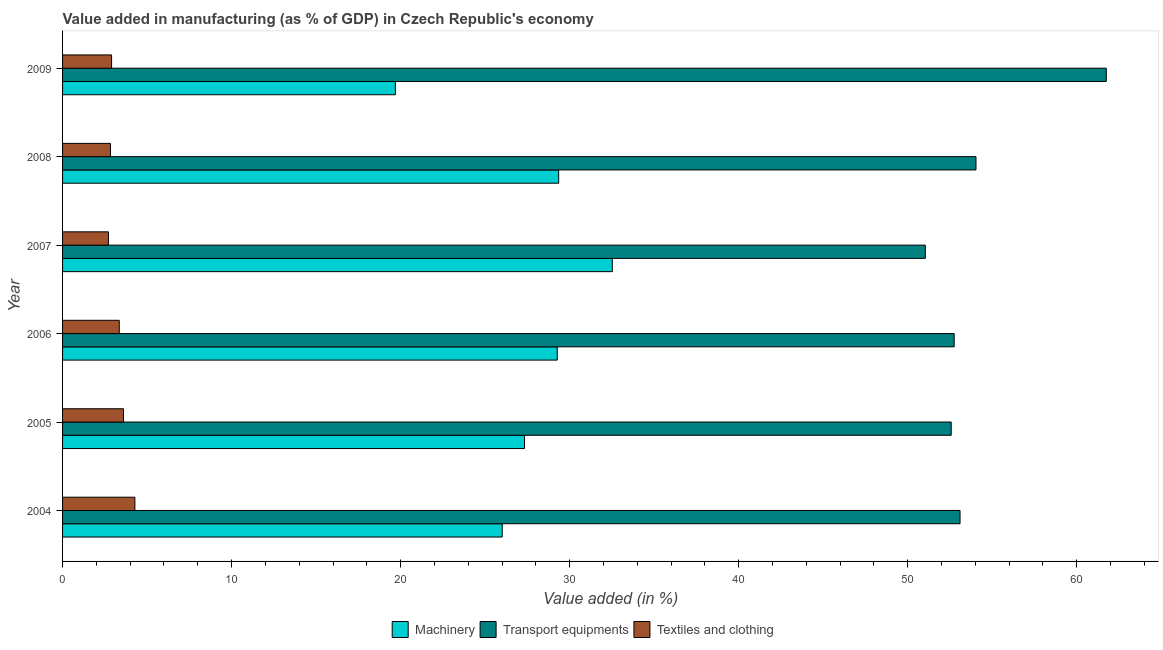How many groups of bars are there?
Keep it short and to the point. 6. Are the number of bars on each tick of the Y-axis equal?
Your answer should be compact. Yes. How many bars are there on the 1st tick from the top?
Your response must be concise. 3. How many bars are there on the 4th tick from the bottom?
Provide a short and direct response. 3. In how many cases, is the number of bars for a given year not equal to the number of legend labels?
Keep it short and to the point. 0. What is the value added in manufacturing textile and clothing in 2006?
Your response must be concise. 3.35. Across all years, what is the maximum value added in manufacturing textile and clothing?
Keep it short and to the point. 4.28. Across all years, what is the minimum value added in manufacturing machinery?
Ensure brevity in your answer.  19.69. In which year was the value added in manufacturing machinery maximum?
Provide a short and direct response. 2007. In which year was the value added in manufacturing machinery minimum?
Provide a succinct answer. 2009. What is the total value added in manufacturing transport equipments in the graph?
Provide a succinct answer. 325.25. What is the difference between the value added in manufacturing textile and clothing in 2006 and that in 2008?
Offer a terse response. 0.52. What is the difference between the value added in manufacturing textile and clothing in 2006 and the value added in manufacturing transport equipments in 2009?
Provide a succinct answer. -58.4. What is the average value added in manufacturing textile and clothing per year?
Give a very brief answer. 3.28. In the year 2008, what is the difference between the value added in manufacturing textile and clothing and value added in manufacturing machinery?
Provide a succinct answer. -26.52. What is the ratio of the value added in manufacturing transport equipments in 2006 to that in 2007?
Make the answer very short. 1.03. Is the value added in manufacturing transport equipments in 2004 less than that in 2009?
Ensure brevity in your answer.  Yes. What is the difference between the highest and the second highest value added in manufacturing machinery?
Offer a terse response. 3.17. What is the difference between the highest and the lowest value added in manufacturing machinery?
Ensure brevity in your answer.  12.83. In how many years, is the value added in manufacturing machinery greater than the average value added in manufacturing machinery taken over all years?
Your response must be concise. 3. What does the 3rd bar from the top in 2007 represents?
Your answer should be compact. Machinery. What does the 2nd bar from the bottom in 2008 represents?
Offer a terse response. Transport equipments. Is it the case that in every year, the sum of the value added in manufacturing machinery and value added in manufacturing transport equipments is greater than the value added in manufacturing textile and clothing?
Ensure brevity in your answer.  Yes. How many bars are there?
Ensure brevity in your answer.  18. Are all the bars in the graph horizontal?
Your response must be concise. Yes. What is the difference between two consecutive major ticks on the X-axis?
Make the answer very short. 10. Does the graph contain grids?
Your answer should be compact. No. How many legend labels are there?
Keep it short and to the point. 3. How are the legend labels stacked?
Offer a very short reply. Horizontal. What is the title of the graph?
Ensure brevity in your answer.  Value added in manufacturing (as % of GDP) in Czech Republic's economy. Does "Tertiary" appear as one of the legend labels in the graph?
Your answer should be very brief. No. What is the label or title of the X-axis?
Make the answer very short. Value added (in %). What is the label or title of the Y-axis?
Make the answer very short. Year. What is the Value added (in %) of Machinery in 2004?
Your response must be concise. 26.01. What is the Value added (in %) in Transport equipments in 2004?
Provide a short and direct response. 53.1. What is the Value added (in %) in Textiles and clothing in 2004?
Provide a succinct answer. 4.28. What is the Value added (in %) in Machinery in 2005?
Provide a short and direct response. 27.33. What is the Value added (in %) of Transport equipments in 2005?
Provide a succinct answer. 52.57. What is the Value added (in %) in Textiles and clothing in 2005?
Offer a terse response. 3.6. What is the Value added (in %) of Machinery in 2006?
Your answer should be compact. 29.27. What is the Value added (in %) of Transport equipments in 2006?
Your answer should be very brief. 52.75. What is the Value added (in %) of Textiles and clothing in 2006?
Make the answer very short. 3.35. What is the Value added (in %) of Machinery in 2007?
Give a very brief answer. 32.52. What is the Value added (in %) in Transport equipments in 2007?
Your answer should be very brief. 51.04. What is the Value added (in %) of Textiles and clothing in 2007?
Keep it short and to the point. 2.71. What is the Value added (in %) of Machinery in 2008?
Offer a very short reply. 29.35. What is the Value added (in %) of Transport equipments in 2008?
Your answer should be compact. 54.04. What is the Value added (in %) in Textiles and clothing in 2008?
Offer a terse response. 2.83. What is the Value added (in %) of Machinery in 2009?
Make the answer very short. 19.69. What is the Value added (in %) in Transport equipments in 2009?
Your response must be concise. 61.75. What is the Value added (in %) in Textiles and clothing in 2009?
Keep it short and to the point. 2.9. Across all years, what is the maximum Value added (in %) of Machinery?
Make the answer very short. 32.52. Across all years, what is the maximum Value added (in %) in Transport equipments?
Your answer should be compact. 61.75. Across all years, what is the maximum Value added (in %) of Textiles and clothing?
Provide a short and direct response. 4.28. Across all years, what is the minimum Value added (in %) in Machinery?
Give a very brief answer. 19.69. Across all years, what is the minimum Value added (in %) of Transport equipments?
Ensure brevity in your answer.  51.04. Across all years, what is the minimum Value added (in %) in Textiles and clothing?
Ensure brevity in your answer.  2.71. What is the total Value added (in %) of Machinery in the graph?
Make the answer very short. 164.17. What is the total Value added (in %) of Transport equipments in the graph?
Offer a terse response. 325.25. What is the total Value added (in %) in Textiles and clothing in the graph?
Your response must be concise. 19.68. What is the difference between the Value added (in %) in Machinery in 2004 and that in 2005?
Make the answer very short. -1.32. What is the difference between the Value added (in %) of Transport equipments in 2004 and that in 2005?
Provide a succinct answer. 0.52. What is the difference between the Value added (in %) in Textiles and clothing in 2004 and that in 2005?
Your answer should be very brief. 0.68. What is the difference between the Value added (in %) in Machinery in 2004 and that in 2006?
Offer a very short reply. -3.25. What is the difference between the Value added (in %) of Transport equipments in 2004 and that in 2006?
Keep it short and to the point. 0.35. What is the difference between the Value added (in %) in Textiles and clothing in 2004 and that in 2006?
Your answer should be compact. 0.92. What is the difference between the Value added (in %) in Machinery in 2004 and that in 2007?
Offer a very short reply. -6.51. What is the difference between the Value added (in %) in Transport equipments in 2004 and that in 2007?
Ensure brevity in your answer.  2.05. What is the difference between the Value added (in %) of Textiles and clothing in 2004 and that in 2007?
Provide a succinct answer. 1.56. What is the difference between the Value added (in %) of Machinery in 2004 and that in 2008?
Give a very brief answer. -3.34. What is the difference between the Value added (in %) of Transport equipments in 2004 and that in 2008?
Keep it short and to the point. -0.94. What is the difference between the Value added (in %) of Textiles and clothing in 2004 and that in 2008?
Make the answer very short. 1.45. What is the difference between the Value added (in %) in Machinery in 2004 and that in 2009?
Ensure brevity in your answer.  6.32. What is the difference between the Value added (in %) in Transport equipments in 2004 and that in 2009?
Your answer should be very brief. -8.65. What is the difference between the Value added (in %) in Textiles and clothing in 2004 and that in 2009?
Your response must be concise. 1.38. What is the difference between the Value added (in %) in Machinery in 2005 and that in 2006?
Your answer should be very brief. -1.94. What is the difference between the Value added (in %) of Transport equipments in 2005 and that in 2006?
Offer a very short reply. -0.18. What is the difference between the Value added (in %) of Textiles and clothing in 2005 and that in 2006?
Your response must be concise. 0.25. What is the difference between the Value added (in %) in Machinery in 2005 and that in 2007?
Offer a terse response. -5.19. What is the difference between the Value added (in %) of Transport equipments in 2005 and that in 2007?
Your response must be concise. 1.53. What is the difference between the Value added (in %) in Textiles and clothing in 2005 and that in 2007?
Your answer should be compact. 0.89. What is the difference between the Value added (in %) of Machinery in 2005 and that in 2008?
Ensure brevity in your answer.  -2.02. What is the difference between the Value added (in %) of Transport equipments in 2005 and that in 2008?
Your response must be concise. -1.47. What is the difference between the Value added (in %) of Textiles and clothing in 2005 and that in 2008?
Ensure brevity in your answer.  0.77. What is the difference between the Value added (in %) of Machinery in 2005 and that in 2009?
Provide a succinct answer. 7.64. What is the difference between the Value added (in %) in Transport equipments in 2005 and that in 2009?
Ensure brevity in your answer.  -9.18. What is the difference between the Value added (in %) in Textiles and clothing in 2005 and that in 2009?
Give a very brief answer. 0.7. What is the difference between the Value added (in %) of Machinery in 2006 and that in 2007?
Your response must be concise. -3.26. What is the difference between the Value added (in %) in Transport equipments in 2006 and that in 2007?
Provide a succinct answer. 1.71. What is the difference between the Value added (in %) in Textiles and clothing in 2006 and that in 2007?
Ensure brevity in your answer.  0.64. What is the difference between the Value added (in %) of Machinery in 2006 and that in 2008?
Provide a short and direct response. -0.08. What is the difference between the Value added (in %) in Transport equipments in 2006 and that in 2008?
Give a very brief answer. -1.29. What is the difference between the Value added (in %) of Textiles and clothing in 2006 and that in 2008?
Offer a terse response. 0.52. What is the difference between the Value added (in %) in Machinery in 2006 and that in 2009?
Your answer should be very brief. 9.58. What is the difference between the Value added (in %) of Transport equipments in 2006 and that in 2009?
Your response must be concise. -9. What is the difference between the Value added (in %) in Textiles and clothing in 2006 and that in 2009?
Give a very brief answer. 0.45. What is the difference between the Value added (in %) of Machinery in 2007 and that in 2008?
Offer a terse response. 3.17. What is the difference between the Value added (in %) of Transport equipments in 2007 and that in 2008?
Offer a very short reply. -3. What is the difference between the Value added (in %) in Textiles and clothing in 2007 and that in 2008?
Provide a succinct answer. -0.12. What is the difference between the Value added (in %) of Machinery in 2007 and that in 2009?
Your answer should be compact. 12.83. What is the difference between the Value added (in %) in Transport equipments in 2007 and that in 2009?
Make the answer very short. -10.71. What is the difference between the Value added (in %) in Textiles and clothing in 2007 and that in 2009?
Offer a terse response. -0.19. What is the difference between the Value added (in %) of Machinery in 2008 and that in 2009?
Make the answer very short. 9.66. What is the difference between the Value added (in %) in Transport equipments in 2008 and that in 2009?
Provide a succinct answer. -7.71. What is the difference between the Value added (in %) of Textiles and clothing in 2008 and that in 2009?
Make the answer very short. -0.07. What is the difference between the Value added (in %) in Machinery in 2004 and the Value added (in %) in Transport equipments in 2005?
Your answer should be compact. -26.56. What is the difference between the Value added (in %) in Machinery in 2004 and the Value added (in %) in Textiles and clothing in 2005?
Provide a short and direct response. 22.41. What is the difference between the Value added (in %) in Transport equipments in 2004 and the Value added (in %) in Textiles and clothing in 2005?
Offer a terse response. 49.49. What is the difference between the Value added (in %) of Machinery in 2004 and the Value added (in %) of Transport equipments in 2006?
Provide a succinct answer. -26.74. What is the difference between the Value added (in %) of Machinery in 2004 and the Value added (in %) of Textiles and clothing in 2006?
Your response must be concise. 22.66. What is the difference between the Value added (in %) in Transport equipments in 2004 and the Value added (in %) in Textiles and clothing in 2006?
Your answer should be very brief. 49.74. What is the difference between the Value added (in %) in Machinery in 2004 and the Value added (in %) in Transport equipments in 2007?
Provide a short and direct response. -25.03. What is the difference between the Value added (in %) of Machinery in 2004 and the Value added (in %) of Textiles and clothing in 2007?
Make the answer very short. 23.3. What is the difference between the Value added (in %) in Transport equipments in 2004 and the Value added (in %) in Textiles and clothing in 2007?
Your response must be concise. 50.38. What is the difference between the Value added (in %) of Machinery in 2004 and the Value added (in %) of Transport equipments in 2008?
Offer a very short reply. -28.03. What is the difference between the Value added (in %) in Machinery in 2004 and the Value added (in %) in Textiles and clothing in 2008?
Your answer should be compact. 23.18. What is the difference between the Value added (in %) of Transport equipments in 2004 and the Value added (in %) of Textiles and clothing in 2008?
Make the answer very short. 50.26. What is the difference between the Value added (in %) of Machinery in 2004 and the Value added (in %) of Transport equipments in 2009?
Give a very brief answer. -35.74. What is the difference between the Value added (in %) in Machinery in 2004 and the Value added (in %) in Textiles and clothing in 2009?
Your answer should be compact. 23.11. What is the difference between the Value added (in %) of Transport equipments in 2004 and the Value added (in %) of Textiles and clothing in 2009?
Provide a short and direct response. 50.2. What is the difference between the Value added (in %) in Machinery in 2005 and the Value added (in %) in Transport equipments in 2006?
Provide a succinct answer. -25.42. What is the difference between the Value added (in %) of Machinery in 2005 and the Value added (in %) of Textiles and clothing in 2006?
Offer a terse response. 23.97. What is the difference between the Value added (in %) in Transport equipments in 2005 and the Value added (in %) in Textiles and clothing in 2006?
Your answer should be compact. 49.22. What is the difference between the Value added (in %) in Machinery in 2005 and the Value added (in %) in Transport equipments in 2007?
Ensure brevity in your answer.  -23.71. What is the difference between the Value added (in %) in Machinery in 2005 and the Value added (in %) in Textiles and clothing in 2007?
Give a very brief answer. 24.62. What is the difference between the Value added (in %) of Transport equipments in 2005 and the Value added (in %) of Textiles and clothing in 2007?
Provide a short and direct response. 49.86. What is the difference between the Value added (in %) in Machinery in 2005 and the Value added (in %) in Transport equipments in 2008?
Provide a succinct answer. -26.71. What is the difference between the Value added (in %) in Machinery in 2005 and the Value added (in %) in Textiles and clothing in 2008?
Provide a succinct answer. 24.5. What is the difference between the Value added (in %) in Transport equipments in 2005 and the Value added (in %) in Textiles and clothing in 2008?
Provide a short and direct response. 49.74. What is the difference between the Value added (in %) of Machinery in 2005 and the Value added (in %) of Transport equipments in 2009?
Your answer should be very brief. -34.42. What is the difference between the Value added (in %) in Machinery in 2005 and the Value added (in %) in Textiles and clothing in 2009?
Make the answer very short. 24.43. What is the difference between the Value added (in %) in Transport equipments in 2005 and the Value added (in %) in Textiles and clothing in 2009?
Your answer should be very brief. 49.67. What is the difference between the Value added (in %) in Machinery in 2006 and the Value added (in %) in Transport equipments in 2007?
Offer a terse response. -21.78. What is the difference between the Value added (in %) in Machinery in 2006 and the Value added (in %) in Textiles and clothing in 2007?
Your response must be concise. 26.55. What is the difference between the Value added (in %) in Transport equipments in 2006 and the Value added (in %) in Textiles and clothing in 2007?
Offer a terse response. 50.04. What is the difference between the Value added (in %) in Machinery in 2006 and the Value added (in %) in Transport equipments in 2008?
Offer a very short reply. -24.77. What is the difference between the Value added (in %) of Machinery in 2006 and the Value added (in %) of Textiles and clothing in 2008?
Make the answer very short. 26.43. What is the difference between the Value added (in %) in Transport equipments in 2006 and the Value added (in %) in Textiles and clothing in 2008?
Give a very brief answer. 49.92. What is the difference between the Value added (in %) in Machinery in 2006 and the Value added (in %) in Transport equipments in 2009?
Give a very brief answer. -32.48. What is the difference between the Value added (in %) of Machinery in 2006 and the Value added (in %) of Textiles and clothing in 2009?
Keep it short and to the point. 26.37. What is the difference between the Value added (in %) of Transport equipments in 2006 and the Value added (in %) of Textiles and clothing in 2009?
Keep it short and to the point. 49.85. What is the difference between the Value added (in %) of Machinery in 2007 and the Value added (in %) of Transport equipments in 2008?
Give a very brief answer. -21.52. What is the difference between the Value added (in %) of Machinery in 2007 and the Value added (in %) of Textiles and clothing in 2008?
Provide a succinct answer. 29.69. What is the difference between the Value added (in %) in Transport equipments in 2007 and the Value added (in %) in Textiles and clothing in 2008?
Give a very brief answer. 48.21. What is the difference between the Value added (in %) in Machinery in 2007 and the Value added (in %) in Transport equipments in 2009?
Ensure brevity in your answer.  -29.23. What is the difference between the Value added (in %) in Machinery in 2007 and the Value added (in %) in Textiles and clothing in 2009?
Provide a succinct answer. 29.62. What is the difference between the Value added (in %) of Transport equipments in 2007 and the Value added (in %) of Textiles and clothing in 2009?
Keep it short and to the point. 48.14. What is the difference between the Value added (in %) of Machinery in 2008 and the Value added (in %) of Transport equipments in 2009?
Keep it short and to the point. -32.4. What is the difference between the Value added (in %) of Machinery in 2008 and the Value added (in %) of Textiles and clothing in 2009?
Keep it short and to the point. 26.45. What is the difference between the Value added (in %) of Transport equipments in 2008 and the Value added (in %) of Textiles and clothing in 2009?
Your answer should be very brief. 51.14. What is the average Value added (in %) of Machinery per year?
Make the answer very short. 27.36. What is the average Value added (in %) of Transport equipments per year?
Keep it short and to the point. 54.21. What is the average Value added (in %) in Textiles and clothing per year?
Make the answer very short. 3.28. In the year 2004, what is the difference between the Value added (in %) of Machinery and Value added (in %) of Transport equipments?
Make the answer very short. -27.08. In the year 2004, what is the difference between the Value added (in %) of Machinery and Value added (in %) of Textiles and clothing?
Provide a succinct answer. 21.73. In the year 2004, what is the difference between the Value added (in %) in Transport equipments and Value added (in %) in Textiles and clothing?
Your response must be concise. 48.82. In the year 2005, what is the difference between the Value added (in %) of Machinery and Value added (in %) of Transport equipments?
Your answer should be very brief. -25.24. In the year 2005, what is the difference between the Value added (in %) of Machinery and Value added (in %) of Textiles and clothing?
Ensure brevity in your answer.  23.73. In the year 2005, what is the difference between the Value added (in %) of Transport equipments and Value added (in %) of Textiles and clothing?
Your response must be concise. 48.97. In the year 2006, what is the difference between the Value added (in %) of Machinery and Value added (in %) of Transport equipments?
Offer a very short reply. -23.48. In the year 2006, what is the difference between the Value added (in %) of Machinery and Value added (in %) of Textiles and clothing?
Provide a succinct answer. 25.91. In the year 2006, what is the difference between the Value added (in %) in Transport equipments and Value added (in %) in Textiles and clothing?
Offer a terse response. 49.4. In the year 2007, what is the difference between the Value added (in %) in Machinery and Value added (in %) in Transport equipments?
Provide a succinct answer. -18.52. In the year 2007, what is the difference between the Value added (in %) of Machinery and Value added (in %) of Textiles and clothing?
Your response must be concise. 29.81. In the year 2007, what is the difference between the Value added (in %) of Transport equipments and Value added (in %) of Textiles and clothing?
Your answer should be very brief. 48.33. In the year 2008, what is the difference between the Value added (in %) in Machinery and Value added (in %) in Transport equipments?
Offer a terse response. -24.69. In the year 2008, what is the difference between the Value added (in %) of Machinery and Value added (in %) of Textiles and clothing?
Keep it short and to the point. 26.52. In the year 2008, what is the difference between the Value added (in %) in Transport equipments and Value added (in %) in Textiles and clothing?
Ensure brevity in your answer.  51.21. In the year 2009, what is the difference between the Value added (in %) in Machinery and Value added (in %) in Transport equipments?
Provide a succinct answer. -42.06. In the year 2009, what is the difference between the Value added (in %) of Machinery and Value added (in %) of Textiles and clothing?
Your response must be concise. 16.79. In the year 2009, what is the difference between the Value added (in %) of Transport equipments and Value added (in %) of Textiles and clothing?
Make the answer very short. 58.85. What is the ratio of the Value added (in %) of Machinery in 2004 to that in 2005?
Your answer should be very brief. 0.95. What is the ratio of the Value added (in %) in Textiles and clothing in 2004 to that in 2005?
Your answer should be compact. 1.19. What is the ratio of the Value added (in %) of Machinery in 2004 to that in 2006?
Offer a terse response. 0.89. What is the ratio of the Value added (in %) of Transport equipments in 2004 to that in 2006?
Give a very brief answer. 1.01. What is the ratio of the Value added (in %) in Textiles and clothing in 2004 to that in 2006?
Your answer should be compact. 1.28. What is the ratio of the Value added (in %) of Machinery in 2004 to that in 2007?
Your answer should be compact. 0.8. What is the ratio of the Value added (in %) in Transport equipments in 2004 to that in 2007?
Your answer should be very brief. 1.04. What is the ratio of the Value added (in %) of Textiles and clothing in 2004 to that in 2007?
Your answer should be compact. 1.58. What is the ratio of the Value added (in %) of Machinery in 2004 to that in 2008?
Provide a short and direct response. 0.89. What is the ratio of the Value added (in %) of Transport equipments in 2004 to that in 2008?
Offer a very short reply. 0.98. What is the ratio of the Value added (in %) of Textiles and clothing in 2004 to that in 2008?
Offer a very short reply. 1.51. What is the ratio of the Value added (in %) in Machinery in 2004 to that in 2009?
Your response must be concise. 1.32. What is the ratio of the Value added (in %) in Transport equipments in 2004 to that in 2009?
Provide a succinct answer. 0.86. What is the ratio of the Value added (in %) in Textiles and clothing in 2004 to that in 2009?
Provide a succinct answer. 1.48. What is the ratio of the Value added (in %) in Machinery in 2005 to that in 2006?
Provide a short and direct response. 0.93. What is the ratio of the Value added (in %) in Textiles and clothing in 2005 to that in 2006?
Keep it short and to the point. 1.07. What is the ratio of the Value added (in %) in Machinery in 2005 to that in 2007?
Ensure brevity in your answer.  0.84. What is the ratio of the Value added (in %) of Textiles and clothing in 2005 to that in 2007?
Offer a terse response. 1.33. What is the ratio of the Value added (in %) of Machinery in 2005 to that in 2008?
Make the answer very short. 0.93. What is the ratio of the Value added (in %) of Transport equipments in 2005 to that in 2008?
Keep it short and to the point. 0.97. What is the ratio of the Value added (in %) of Textiles and clothing in 2005 to that in 2008?
Provide a succinct answer. 1.27. What is the ratio of the Value added (in %) in Machinery in 2005 to that in 2009?
Provide a succinct answer. 1.39. What is the ratio of the Value added (in %) of Transport equipments in 2005 to that in 2009?
Provide a short and direct response. 0.85. What is the ratio of the Value added (in %) in Textiles and clothing in 2005 to that in 2009?
Make the answer very short. 1.24. What is the ratio of the Value added (in %) of Machinery in 2006 to that in 2007?
Your answer should be very brief. 0.9. What is the ratio of the Value added (in %) in Transport equipments in 2006 to that in 2007?
Make the answer very short. 1.03. What is the ratio of the Value added (in %) of Textiles and clothing in 2006 to that in 2007?
Offer a very short reply. 1.24. What is the ratio of the Value added (in %) in Machinery in 2006 to that in 2008?
Give a very brief answer. 1. What is the ratio of the Value added (in %) of Transport equipments in 2006 to that in 2008?
Your answer should be very brief. 0.98. What is the ratio of the Value added (in %) of Textiles and clothing in 2006 to that in 2008?
Keep it short and to the point. 1.18. What is the ratio of the Value added (in %) in Machinery in 2006 to that in 2009?
Make the answer very short. 1.49. What is the ratio of the Value added (in %) in Transport equipments in 2006 to that in 2009?
Provide a succinct answer. 0.85. What is the ratio of the Value added (in %) of Textiles and clothing in 2006 to that in 2009?
Provide a succinct answer. 1.16. What is the ratio of the Value added (in %) of Machinery in 2007 to that in 2008?
Keep it short and to the point. 1.11. What is the ratio of the Value added (in %) of Transport equipments in 2007 to that in 2008?
Offer a terse response. 0.94. What is the ratio of the Value added (in %) in Textiles and clothing in 2007 to that in 2008?
Provide a succinct answer. 0.96. What is the ratio of the Value added (in %) of Machinery in 2007 to that in 2009?
Provide a succinct answer. 1.65. What is the ratio of the Value added (in %) in Transport equipments in 2007 to that in 2009?
Your answer should be very brief. 0.83. What is the ratio of the Value added (in %) in Textiles and clothing in 2007 to that in 2009?
Your answer should be compact. 0.94. What is the ratio of the Value added (in %) of Machinery in 2008 to that in 2009?
Keep it short and to the point. 1.49. What is the ratio of the Value added (in %) in Transport equipments in 2008 to that in 2009?
Offer a very short reply. 0.88. What is the ratio of the Value added (in %) in Textiles and clothing in 2008 to that in 2009?
Provide a succinct answer. 0.98. What is the difference between the highest and the second highest Value added (in %) of Machinery?
Your answer should be very brief. 3.17. What is the difference between the highest and the second highest Value added (in %) of Transport equipments?
Provide a short and direct response. 7.71. What is the difference between the highest and the second highest Value added (in %) of Textiles and clothing?
Your response must be concise. 0.68. What is the difference between the highest and the lowest Value added (in %) in Machinery?
Provide a short and direct response. 12.83. What is the difference between the highest and the lowest Value added (in %) of Transport equipments?
Ensure brevity in your answer.  10.71. What is the difference between the highest and the lowest Value added (in %) of Textiles and clothing?
Give a very brief answer. 1.56. 